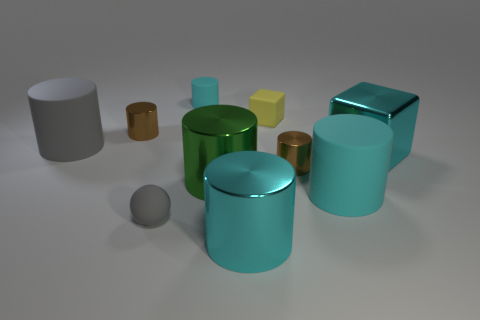Subtract all cyan cubes. How many brown cylinders are left? 2 Subtract all large metallic cylinders. How many cylinders are left? 5 Subtract 5 cylinders. How many cylinders are left? 2 Subtract all brown cylinders. How many cylinders are left? 5 Subtract all cylinders. How many objects are left? 3 Add 4 metallic cylinders. How many metallic cylinders exist? 8 Subtract 1 cyan cubes. How many objects are left? 9 Subtract all purple balls. Subtract all gray cylinders. How many balls are left? 1 Subtract all blue metal cylinders. Subtract all small cyan things. How many objects are left? 9 Add 2 small brown metallic things. How many small brown metallic things are left? 4 